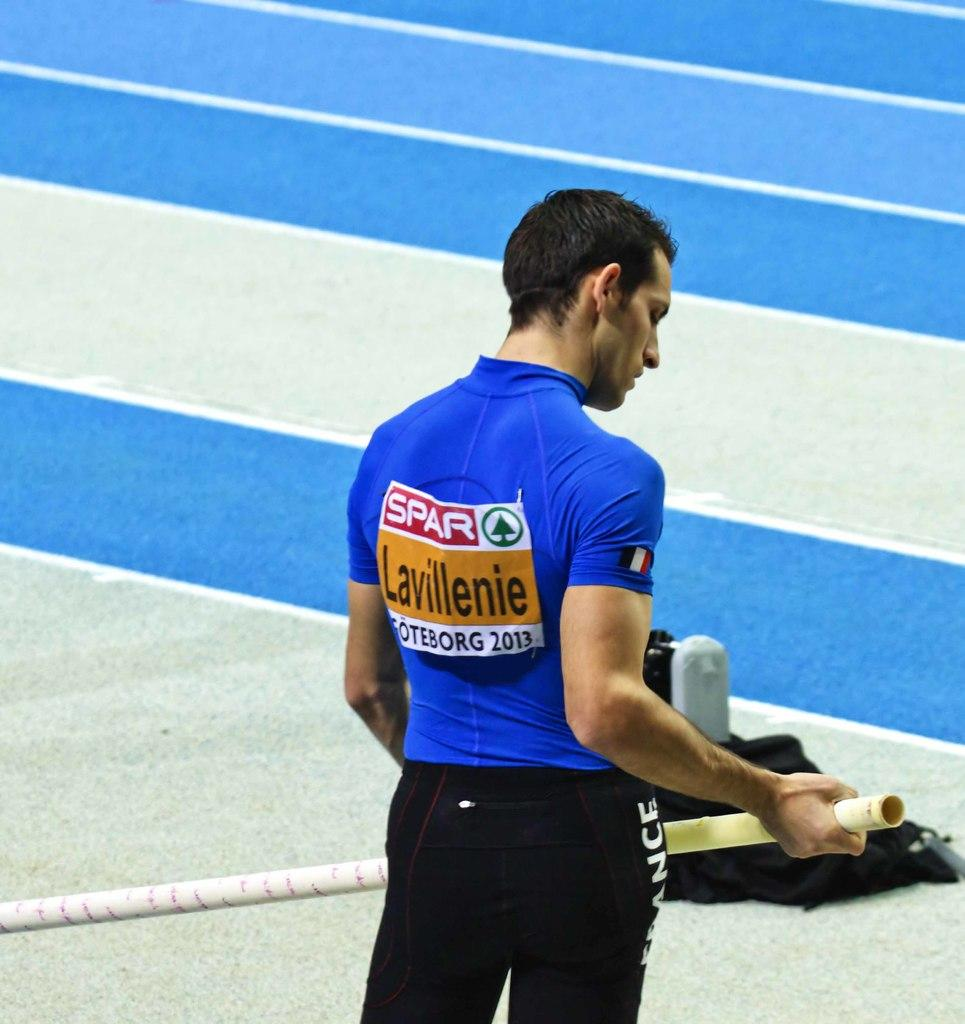<image>
Offer a succinct explanation of the picture presented. A young man in a blue shirt with the words Lavillenie on the back is at a pole vaulting event. 